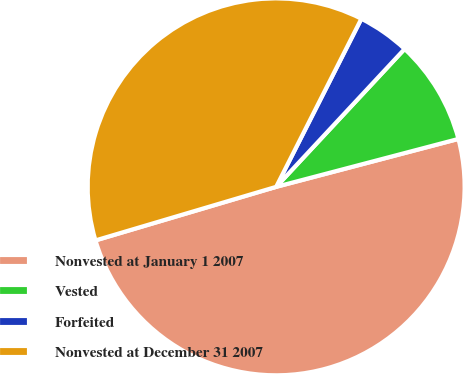Convert chart. <chart><loc_0><loc_0><loc_500><loc_500><pie_chart><fcel>Nonvested at January 1 2007<fcel>Vested<fcel>Forfeited<fcel>Nonvested at December 31 2007<nl><fcel>49.5%<fcel>8.97%<fcel>4.47%<fcel>37.05%<nl></chart> 